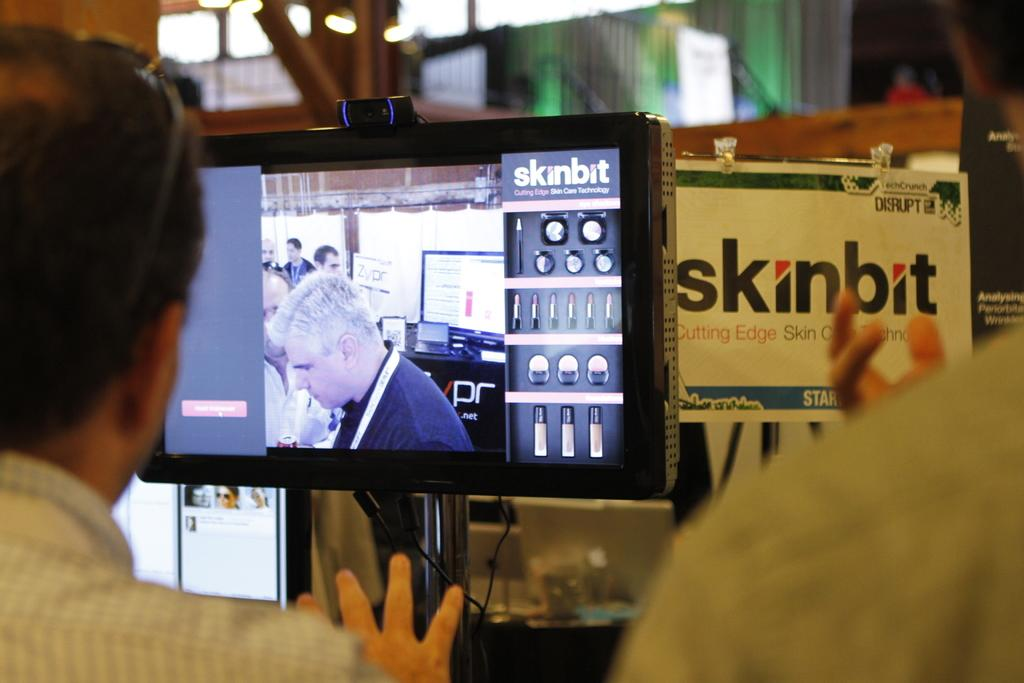Provide a one-sentence caption for the provided image. a disply with a flat screen tv advertising the skinbit. 